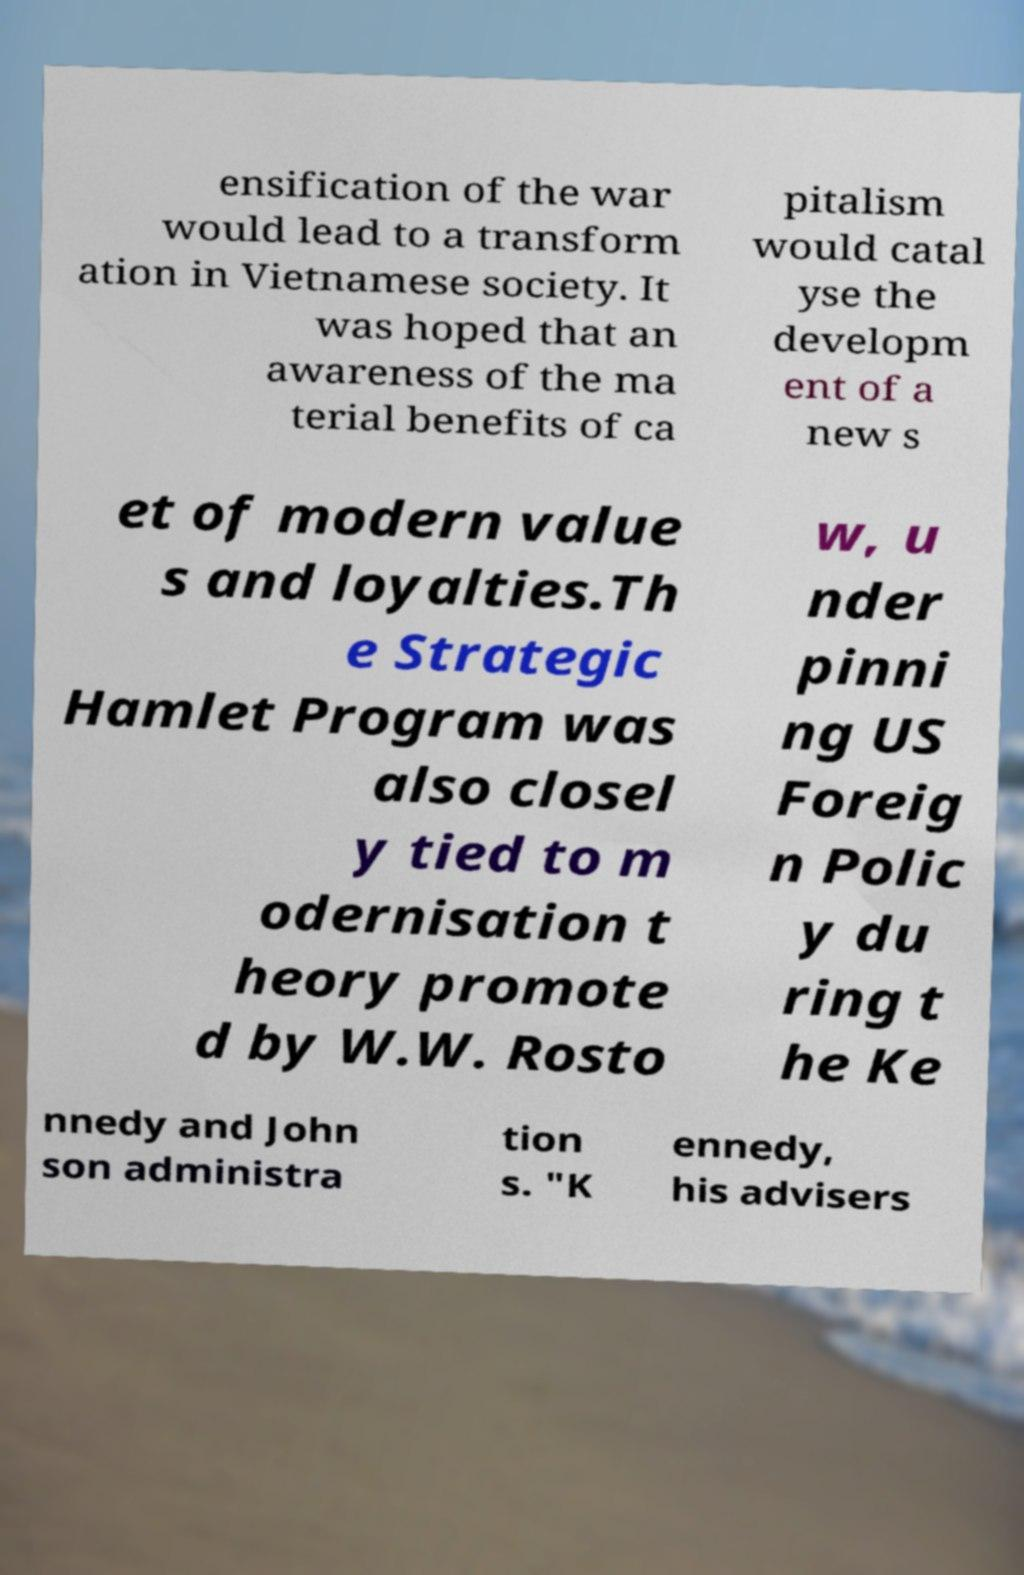What messages or text are displayed in this image? I need them in a readable, typed format. ensification of the war would lead to a transform ation in Vietnamese society. It was hoped that an awareness of the ma terial benefits of ca pitalism would catal yse the developm ent of a new s et of modern value s and loyalties.Th e Strategic Hamlet Program was also closel y tied to m odernisation t heory promote d by W.W. Rosto w, u nder pinni ng US Foreig n Polic y du ring t he Ke nnedy and John son administra tion s. "K ennedy, his advisers 